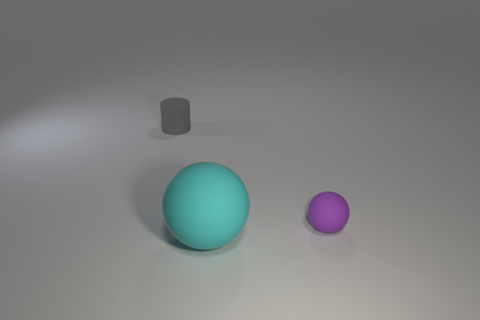Is the number of purple objects greater than the number of matte balls?
Give a very brief answer. No. What number of objects are either objects that are to the right of the small rubber cylinder or small yellow shiny balls?
Your response must be concise. 2. There is a object that is behind the purple rubber ball; what number of spheres are behind it?
Provide a short and direct response. 0. What size is the matte object that is to the right of the sphere that is in front of the small rubber object that is on the right side of the gray thing?
Your response must be concise. Small. There is a thing behind the purple ball; is its color the same as the large thing?
Ensure brevity in your answer.  No. What size is the cyan matte object that is the same shape as the purple object?
Offer a terse response. Large. How many objects are either things to the right of the gray rubber cylinder or rubber things that are right of the small matte cylinder?
Give a very brief answer. 2. What is the shape of the tiny matte object to the left of the sphere left of the small purple matte object?
Your answer should be compact. Cylinder. Are there any other things that have the same size as the cyan rubber object?
Provide a succinct answer. No. How many objects are either small shiny spheres or matte objects?
Offer a very short reply. 3. 